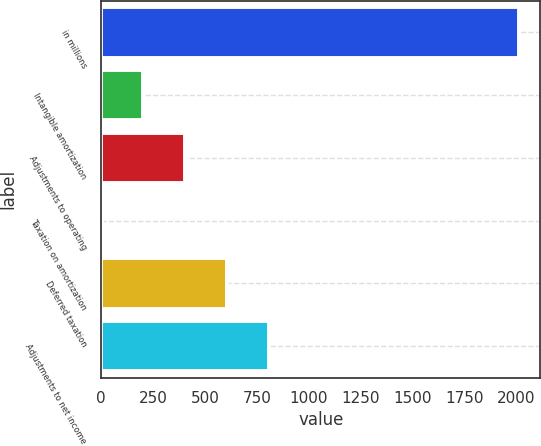<chart> <loc_0><loc_0><loc_500><loc_500><bar_chart><fcel>in millions<fcel>Intangible amortization<fcel>Adjustments to operating<fcel>Taxation on amortization<fcel>Deferred taxation<fcel>Adjustments to net income<nl><fcel>2014<fcel>202.84<fcel>404.08<fcel>1.6<fcel>605.32<fcel>806.56<nl></chart> 